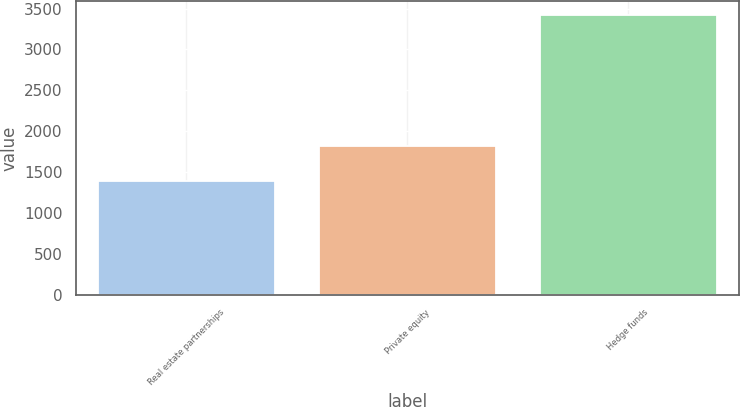Convert chart. <chart><loc_0><loc_0><loc_500><loc_500><bar_chart><fcel>Real estate partnerships<fcel>Private equity<fcel>Hedge funds<nl><fcel>1394<fcel>1819<fcel>3417<nl></chart> 